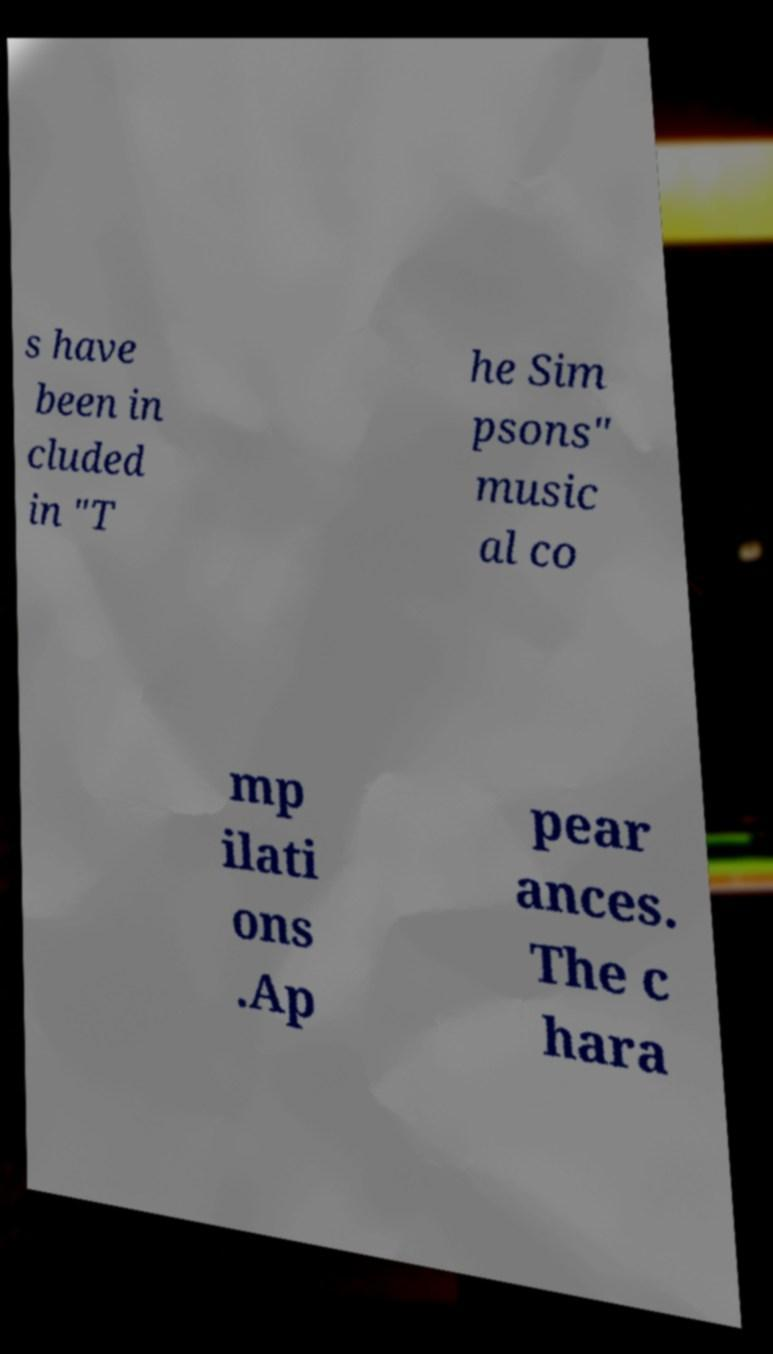For documentation purposes, I need the text within this image transcribed. Could you provide that? s have been in cluded in "T he Sim psons" music al co mp ilati ons .Ap pear ances. The c hara 